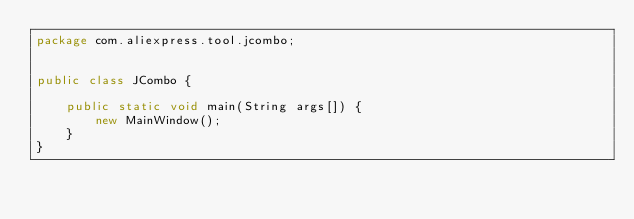Convert code to text. <code><loc_0><loc_0><loc_500><loc_500><_Java_>package com.aliexpress.tool.jcombo;


public class JCombo {

    public static void main(String args[]) {
        new MainWindow();
    }
}</code> 